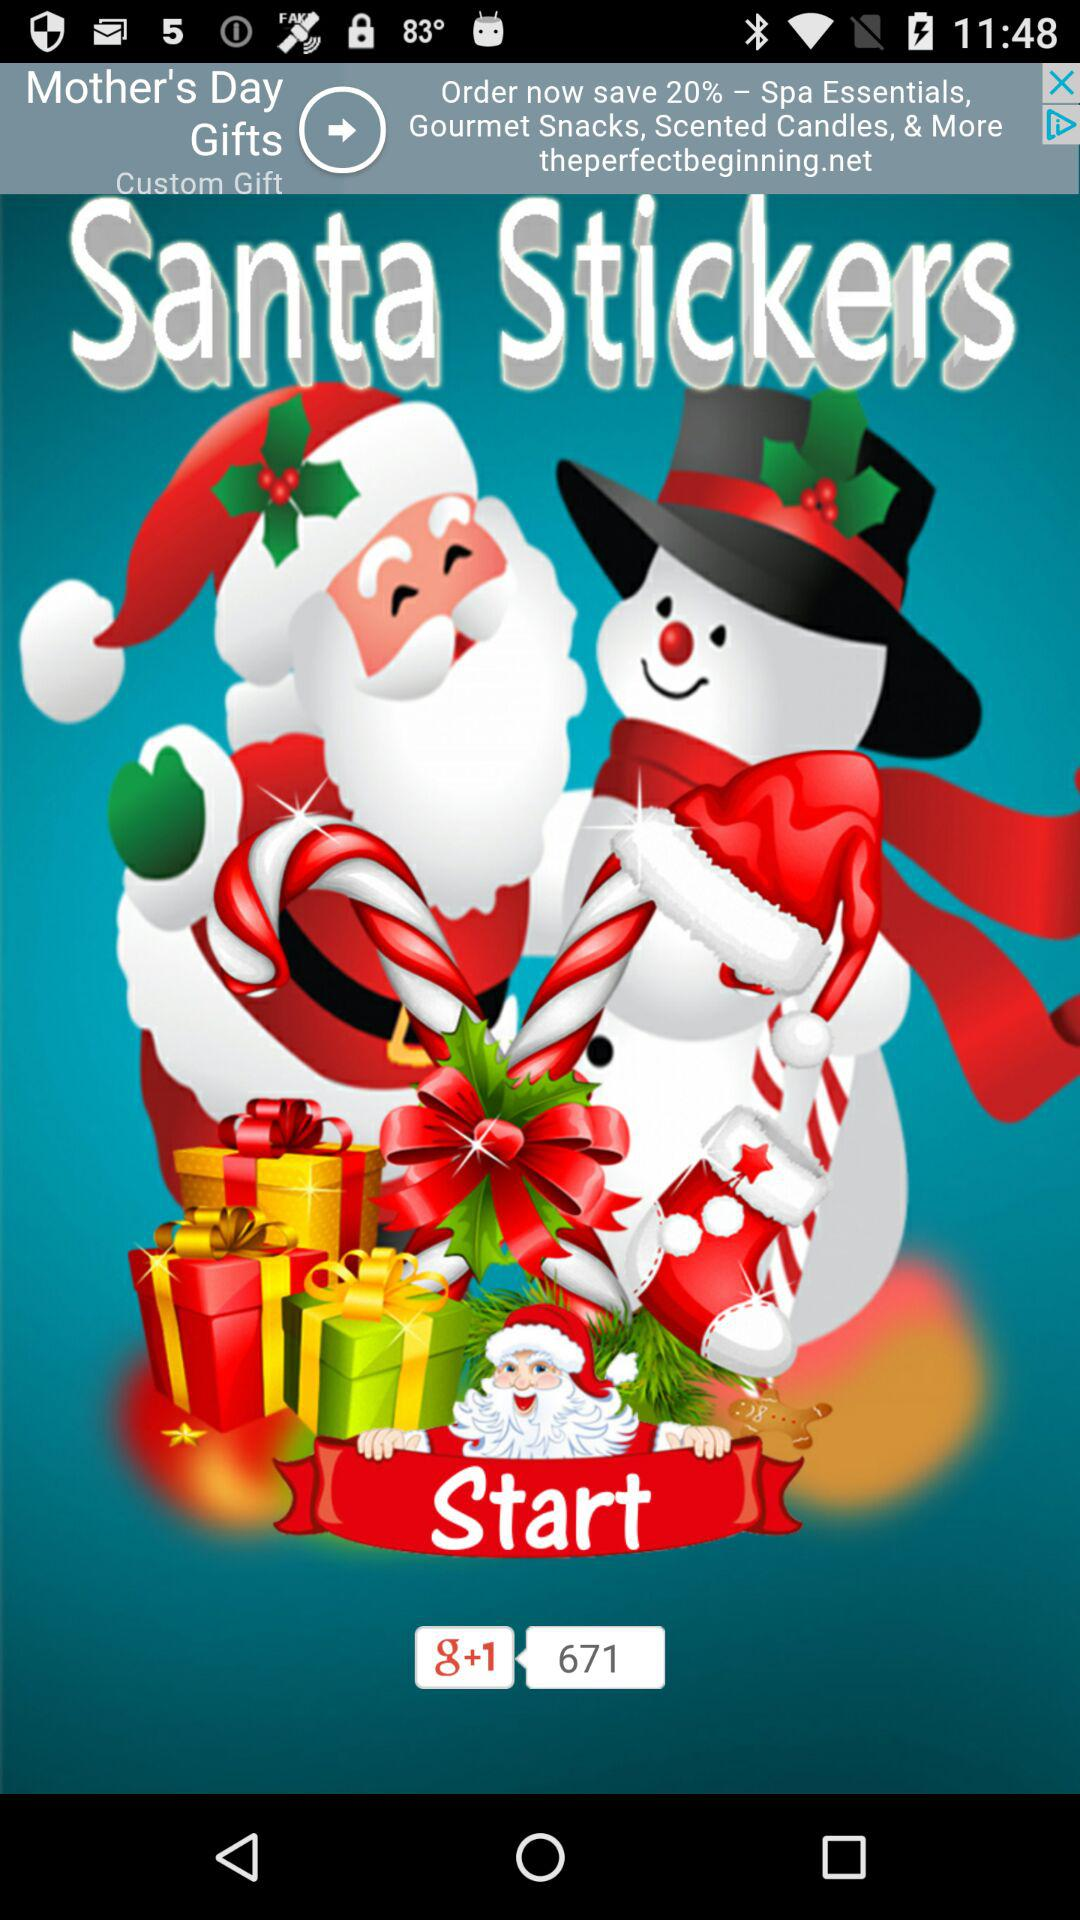How many recommendations are there on "g+1"? There are 671 recommendations on "g+1". 